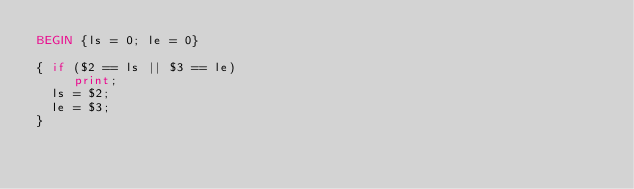<code> <loc_0><loc_0><loc_500><loc_500><_Awk_>BEGIN {ls = 0; le = 0}

{ if ($2 == ls || $3 == le)
     print;
  ls = $2;
  le = $3;
}
</code> 